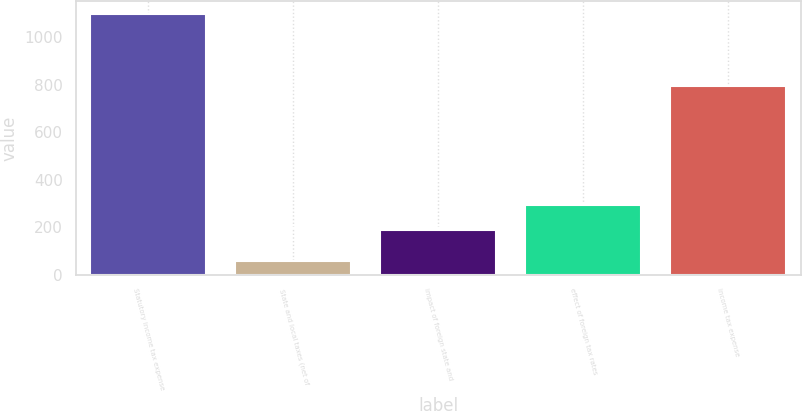Convert chart to OTSL. <chart><loc_0><loc_0><loc_500><loc_500><bar_chart><fcel>Statutory income tax expense<fcel>State and local taxes (net of<fcel>impact of foreign state and<fcel>effect of foreign tax rates<fcel>income tax expense<nl><fcel>1097<fcel>59<fcel>188<fcel>291.8<fcel>796<nl></chart> 